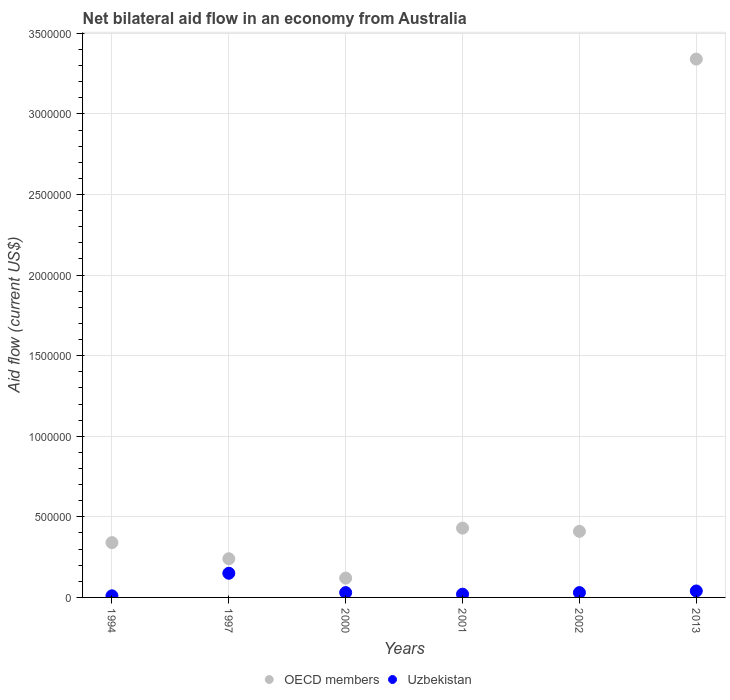Is the number of dotlines equal to the number of legend labels?
Keep it short and to the point. Yes. What is the net bilateral aid flow in OECD members in 2001?
Your response must be concise. 4.30e+05. Across all years, what is the maximum net bilateral aid flow in OECD members?
Offer a very short reply. 3.34e+06. In which year was the net bilateral aid flow in Uzbekistan maximum?
Provide a short and direct response. 1997. In which year was the net bilateral aid flow in Uzbekistan minimum?
Offer a terse response. 1994. What is the total net bilateral aid flow in Uzbekistan in the graph?
Keep it short and to the point. 2.80e+05. What is the difference between the net bilateral aid flow in Uzbekistan in 2013 and the net bilateral aid flow in OECD members in 2001?
Provide a succinct answer. -3.90e+05. What is the average net bilateral aid flow in Uzbekistan per year?
Provide a short and direct response. 4.67e+04. What is the ratio of the net bilateral aid flow in OECD members in 2001 to that in 2013?
Offer a very short reply. 0.13. Is the net bilateral aid flow in Uzbekistan in 2000 less than that in 2002?
Offer a very short reply. No. What is the difference between the highest and the lowest net bilateral aid flow in Uzbekistan?
Your answer should be compact. 1.40e+05. Does the net bilateral aid flow in OECD members monotonically increase over the years?
Offer a very short reply. No. Is the net bilateral aid flow in OECD members strictly greater than the net bilateral aid flow in Uzbekistan over the years?
Provide a short and direct response. Yes. Is the net bilateral aid flow in Uzbekistan strictly less than the net bilateral aid flow in OECD members over the years?
Your response must be concise. Yes. How many dotlines are there?
Make the answer very short. 2. What is the difference between two consecutive major ticks on the Y-axis?
Your answer should be compact. 5.00e+05. Are the values on the major ticks of Y-axis written in scientific E-notation?
Give a very brief answer. No. Does the graph contain any zero values?
Your answer should be very brief. No. Where does the legend appear in the graph?
Give a very brief answer. Bottom center. How many legend labels are there?
Provide a short and direct response. 2. How are the legend labels stacked?
Provide a short and direct response. Horizontal. What is the title of the graph?
Keep it short and to the point. Net bilateral aid flow in an economy from Australia. What is the label or title of the X-axis?
Your response must be concise. Years. What is the Aid flow (current US$) of OECD members in 1994?
Your answer should be very brief. 3.40e+05. What is the Aid flow (current US$) in Uzbekistan in 1994?
Give a very brief answer. 10000. What is the Aid flow (current US$) of Uzbekistan in 1997?
Offer a terse response. 1.50e+05. What is the Aid flow (current US$) of OECD members in 2001?
Provide a short and direct response. 4.30e+05. What is the Aid flow (current US$) in OECD members in 2002?
Ensure brevity in your answer.  4.10e+05. What is the Aid flow (current US$) of OECD members in 2013?
Offer a terse response. 3.34e+06. What is the Aid flow (current US$) of Uzbekistan in 2013?
Make the answer very short. 4.00e+04. Across all years, what is the maximum Aid flow (current US$) in OECD members?
Offer a very short reply. 3.34e+06. Across all years, what is the maximum Aid flow (current US$) of Uzbekistan?
Your answer should be very brief. 1.50e+05. Across all years, what is the minimum Aid flow (current US$) in OECD members?
Give a very brief answer. 1.20e+05. Across all years, what is the minimum Aid flow (current US$) in Uzbekistan?
Give a very brief answer. 10000. What is the total Aid flow (current US$) in OECD members in the graph?
Offer a terse response. 4.88e+06. What is the total Aid flow (current US$) of Uzbekistan in the graph?
Make the answer very short. 2.80e+05. What is the difference between the Aid flow (current US$) in Uzbekistan in 1994 and that in 1997?
Make the answer very short. -1.40e+05. What is the difference between the Aid flow (current US$) of OECD members in 1994 and that in 2000?
Make the answer very short. 2.20e+05. What is the difference between the Aid flow (current US$) of OECD members in 1994 and that in 2001?
Offer a terse response. -9.00e+04. What is the difference between the Aid flow (current US$) in Uzbekistan in 1994 and that in 2001?
Give a very brief answer. -10000. What is the difference between the Aid flow (current US$) of OECD members in 1994 and that in 2002?
Your response must be concise. -7.00e+04. What is the difference between the Aid flow (current US$) of Uzbekistan in 1994 and that in 2002?
Keep it short and to the point. -2.00e+04. What is the difference between the Aid flow (current US$) of Uzbekistan in 1994 and that in 2013?
Your answer should be compact. -3.00e+04. What is the difference between the Aid flow (current US$) of Uzbekistan in 1997 and that in 2001?
Your answer should be very brief. 1.30e+05. What is the difference between the Aid flow (current US$) in OECD members in 1997 and that in 2002?
Offer a very short reply. -1.70e+05. What is the difference between the Aid flow (current US$) in OECD members in 1997 and that in 2013?
Offer a very short reply. -3.10e+06. What is the difference between the Aid flow (current US$) in Uzbekistan in 1997 and that in 2013?
Provide a short and direct response. 1.10e+05. What is the difference between the Aid flow (current US$) of OECD members in 2000 and that in 2001?
Give a very brief answer. -3.10e+05. What is the difference between the Aid flow (current US$) in OECD members in 2000 and that in 2013?
Keep it short and to the point. -3.22e+06. What is the difference between the Aid flow (current US$) of OECD members in 2001 and that in 2002?
Your response must be concise. 2.00e+04. What is the difference between the Aid flow (current US$) in Uzbekistan in 2001 and that in 2002?
Ensure brevity in your answer.  -10000. What is the difference between the Aid flow (current US$) in OECD members in 2001 and that in 2013?
Make the answer very short. -2.91e+06. What is the difference between the Aid flow (current US$) of Uzbekistan in 2001 and that in 2013?
Provide a short and direct response. -2.00e+04. What is the difference between the Aid flow (current US$) of OECD members in 2002 and that in 2013?
Offer a terse response. -2.93e+06. What is the difference between the Aid flow (current US$) of Uzbekistan in 2002 and that in 2013?
Your response must be concise. -10000. What is the difference between the Aid flow (current US$) of OECD members in 1994 and the Aid flow (current US$) of Uzbekistan in 2000?
Your answer should be compact. 3.10e+05. What is the difference between the Aid flow (current US$) in OECD members in 1994 and the Aid flow (current US$) in Uzbekistan in 2001?
Provide a succinct answer. 3.20e+05. What is the difference between the Aid flow (current US$) in OECD members in 1994 and the Aid flow (current US$) in Uzbekistan in 2002?
Provide a short and direct response. 3.10e+05. What is the difference between the Aid flow (current US$) in OECD members in 1994 and the Aid flow (current US$) in Uzbekistan in 2013?
Offer a very short reply. 3.00e+05. What is the difference between the Aid flow (current US$) in OECD members in 1997 and the Aid flow (current US$) in Uzbekistan in 2002?
Ensure brevity in your answer.  2.10e+05. What is the difference between the Aid flow (current US$) in OECD members in 2000 and the Aid flow (current US$) in Uzbekistan in 2002?
Offer a very short reply. 9.00e+04. What is the difference between the Aid flow (current US$) in OECD members in 2000 and the Aid flow (current US$) in Uzbekistan in 2013?
Provide a short and direct response. 8.00e+04. What is the difference between the Aid flow (current US$) of OECD members in 2001 and the Aid flow (current US$) of Uzbekistan in 2002?
Your answer should be compact. 4.00e+05. What is the average Aid flow (current US$) of OECD members per year?
Offer a terse response. 8.13e+05. What is the average Aid flow (current US$) in Uzbekistan per year?
Your response must be concise. 4.67e+04. In the year 1997, what is the difference between the Aid flow (current US$) in OECD members and Aid flow (current US$) in Uzbekistan?
Ensure brevity in your answer.  9.00e+04. In the year 2013, what is the difference between the Aid flow (current US$) of OECD members and Aid flow (current US$) of Uzbekistan?
Your answer should be compact. 3.30e+06. What is the ratio of the Aid flow (current US$) in OECD members in 1994 to that in 1997?
Give a very brief answer. 1.42. What is the ratio of the Aid flow (current US$) in Uzbekistan in 1994 to that in 1997?
Provide a short and direct response. 0.07. What is the ratio of the Aid flow (current US$) of OECD members in 1994 to that in 2000?
Your answer should be very brief. 2.83. What is the ratio of the Aid flow (current US$) of OECD members in 1994 to that in 2001?
Give a very brief answer. 0.79. What is the ratio of the Aid flow (current US$) of OECD members in 1994 to that in 2002?
Give a very brief answer. 0.83. What is the ratio of the Aid flow (current US$) in OECD members in 1994 to that in 2013?
Make the answer very short. 0.1. What is the ratio of the Aid flow (current US$) in Uzbekistan in 1994 to that in 2013?
Give a very brief answer. 0.25. What is the ratio of the Aid flow (current US$) in OECD members in 1997 to that in 2000?
Offer a terse response. 2. What is the ratio of the Aid flow (current US$) of Uzbekistan in 1997 to that in 2000?
Make the answer very short. 5. What is the ratio of the Aid flow (current US$) of OECD members in 1997 to that in 2001?
Provide a short and direct response. 0.56. What is the ratio of the Aid flow (current US$) of OECD members in 1997 to that in 2002?
Your answer should be compact. 0.59. What is the ratio of the Aid flow (current US$) in Uzbekistan in 1997 to that in 2002?
Provide a succinct answer. 5. What is the ratio of the Aid flow (current US$) in OECD members in 1997 to that in 2013?
Your response must be concise. 0.07. What is the ratio of the Aid flow (current US$) of Uzbekistan in 1997 to that in 2013?
Provide a short and direct response. 3.75. What is the ratio of the Aid flow (current US$) in OECD members in 2000 to that in 2001?
Offer a terse response. 0.28. What is the ratio of the Aid flow (current US$) in Uzbekistan in 2000 to that in 2001?
Give a very brief answer. 1.5. What is the ratio of the Aid flow (current US$) of OECD members in 2000 to that in 2002?
Your answer should be compact. 0.29. What is the ratio of the Aid flow (current US$) of OECD members in 2000 to that in 2013?
Offer a very short reply. 0.04. What is the ratio of the Aid flow (current US$) in Uzbekistan in 2000 to that in 2013?
Make the answer very short. 0.75. What is the ratio of the Aid flow (current US$) in OECD members in 2001 to that in 2002?
Keep it short and to the point. 1.05. What is the ratio of the Aid flow (current US$) of Uzbekistan in 2001 to that in 2002?
Offer a very short reply. 0.67. What is the ratio of the Aid flow (current US$) in OECD members in 2001 to that in 2013?
Provide a succinct answer. 0.13. What is the ratio of the Aid flow (current US$) of Uzbekistan in 2001 to that in 2013?
Offer a very short reply. 0.5. What is the ratio of the Aid flow (current US$) in OECD members in 2002 to that in 2013?
Your response must be concise. 0.12. What is the ratio of the Aid flow (current US$) in Uzbekistan in 2002 to that in 2013?
Make the answer very short. 0.75. What is the difference between the highest and the second highest Aid flow (current US$) in OECD members?
Give a very brief answer. 2.91e+06. What is the difference between the highest and the second highest Aid flow (current US$) in Uzbekistan?
Your response must be concise. 1.10e+05. What is the difference between the highest and the lowest Aid flow (current US$) of OECD members?
Make the answer very short. 3.22e+06. What is the difference between the highest and the lowest Aid flow (current US$) of Uzbekistan?
Offer a terse response. 1.40e+05. 